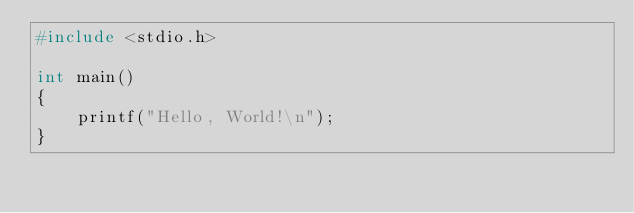Convert code to text. <code><loc_0><loc_0><loc_500><loc_500><_C_>#include <stdio.h>

int main()
{
    printf("Hello, World!\n");
}
</code> 